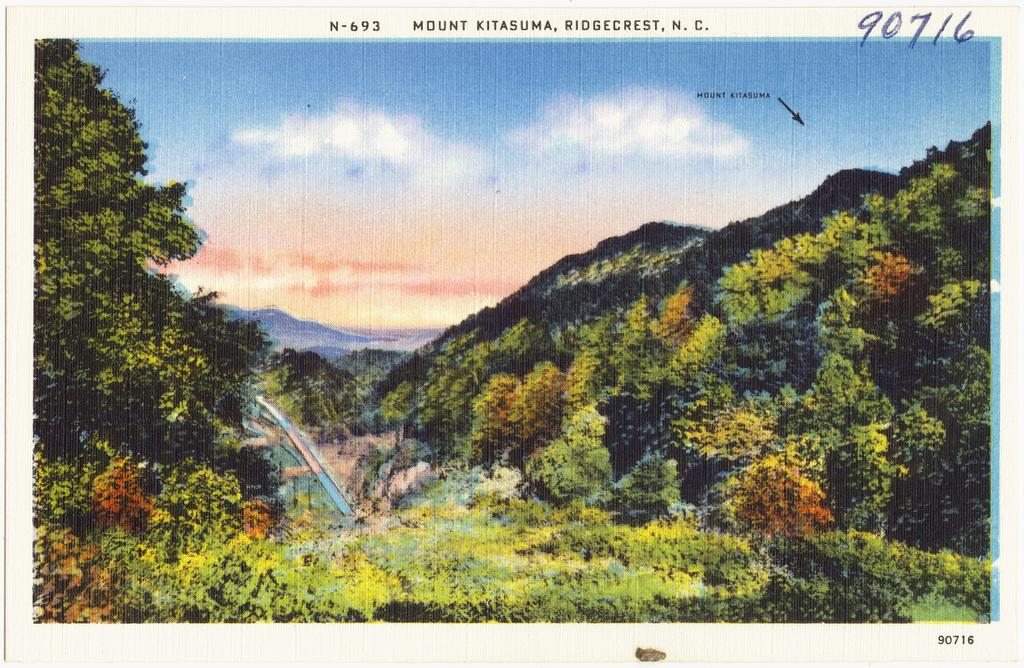What type of image is being described? The image is a photo. What can be seen in the center of the photo? There are hills and trees in the center of the photo. What is visible in the background of the photo? There is sky visible in the background of the photo, and there are clouds present. Where is the grandfather sitting in the photo? There is no grandfather present in the photo. What type of bottle can be seen in the photo? There is no bottle present in the photo. 